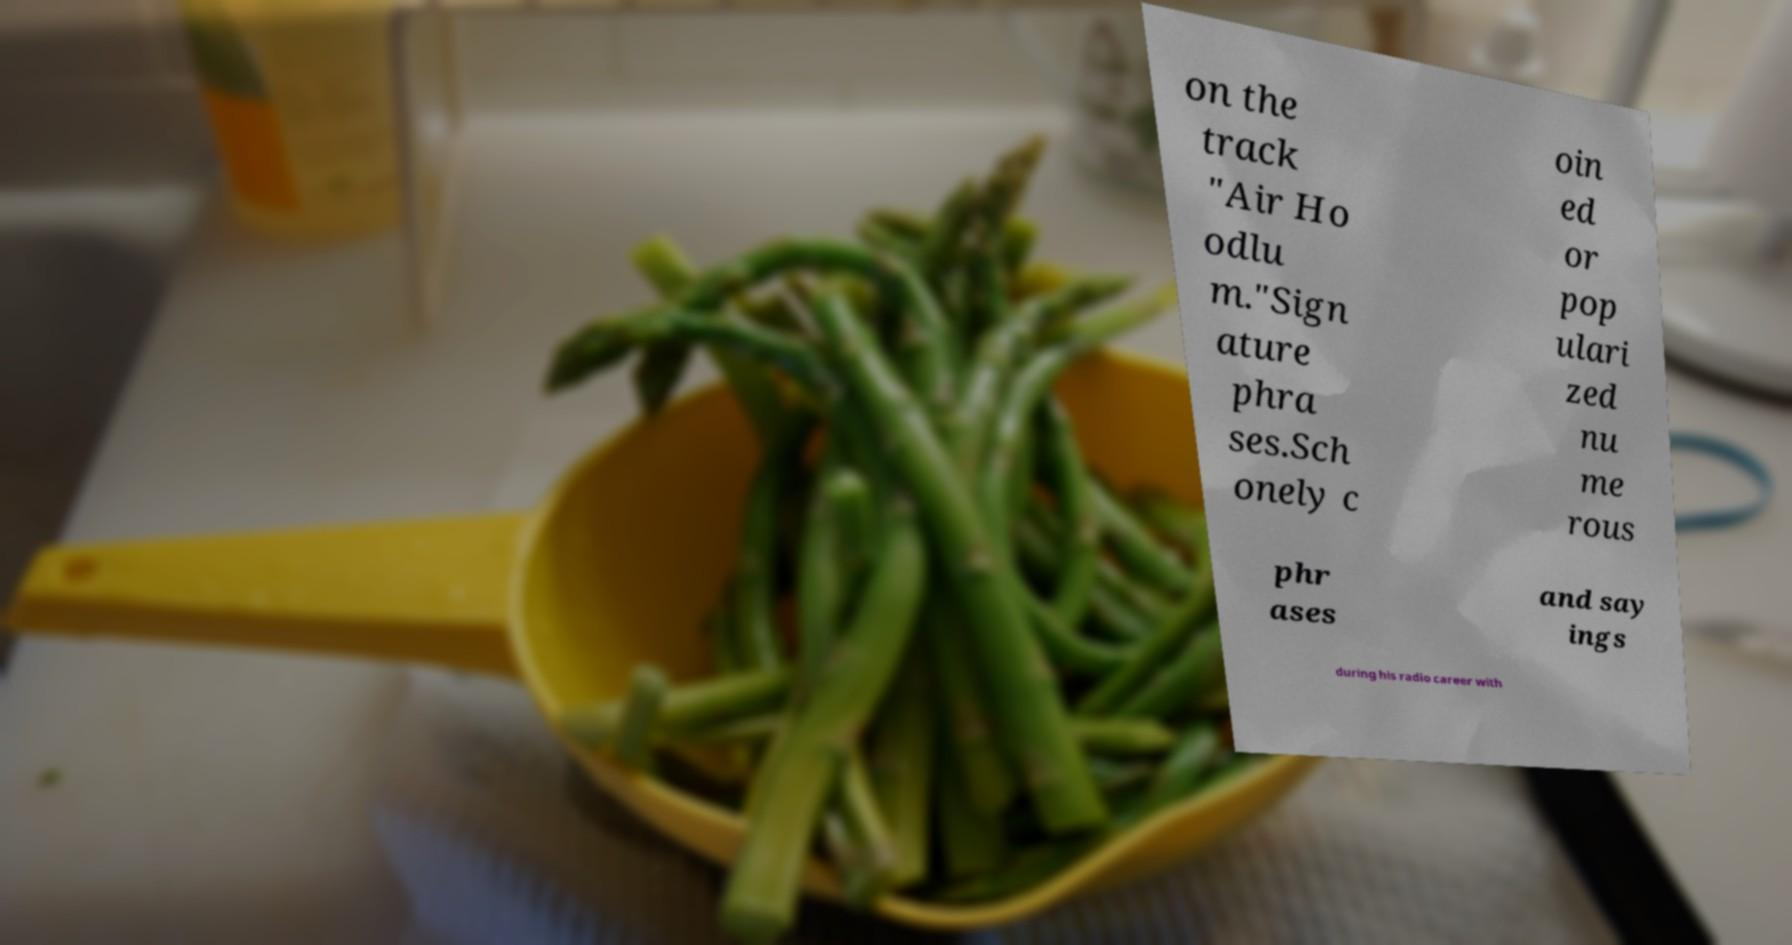Could you extract and type out the text from this image? on the track "Air Ho odlu m."Sign ature phra ses.Sch onely c oin ed or pop ulari zed nu me rous phr ases and say ings during his radio career with 